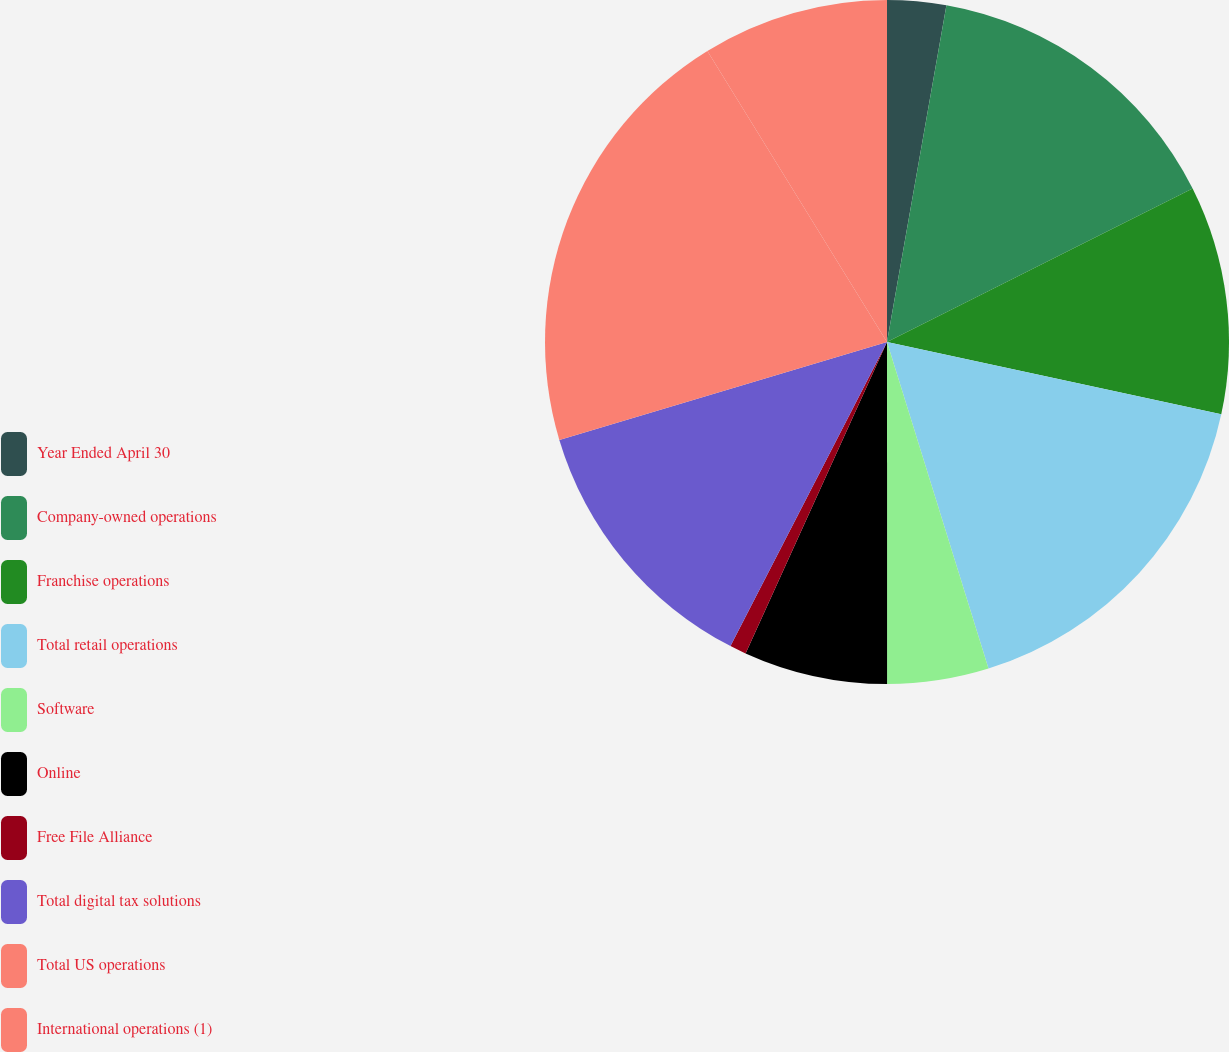Convert chart to OTSL. <chart><loc_0><loc_0><loc_500><loc_500><pie_chart><fcel>Year Ended April 30<fcel>Company-owned operations<fcel>Franchise operations<fcel>Total retail operations<fcel>Software<fcel>Online<fcel>Free File Alliance<fcel>Total digital tax solutions<fcel>Total US operations<fcel>International operations (1)<nl><fcel>2.78%<fcel>14.81%<fcel>10.8%<fcel>16.81%<fcel>4.79%<fcel>6.79%<fcel>0.78%<fcel>12.81%<fcel>20.82%<fcel>8.8%<nl></chart> 